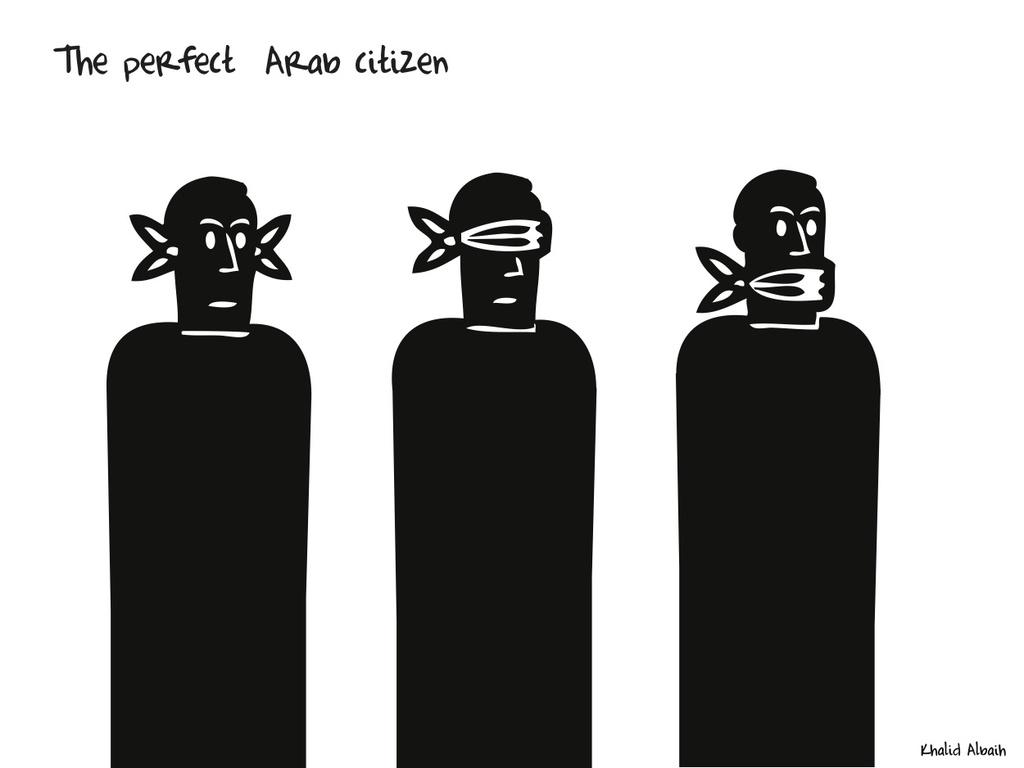What can be seen in the image in terms of visual art? There are three drawings in the image. What is the color of the drawings? The drawings are in black color. Is there any text present in the image? Yes, there is text written at the top of the image. Can you hear the voice of the artist in the image? There is no voice present in the image, as it is a visual representation of drawings and text. 